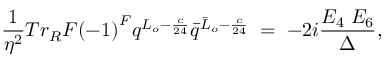<formula> <loc_0><loc_0><loc_500><loc_500>\frac { 1 } { \eta ^ { 2 } } { T r _ { R } } F { ( - 1 ) } ^ { F } q ^ { L _ { o } - \frac { c } { 2 4 } } { \bar { q } } ^ { { \bar { L } } _ { o } - \frac { c } { 2 4 } } \, = \, - 2 i \frac { E _ { 4 } \, E _ { 6 } } { \Delta } ,</formula> 